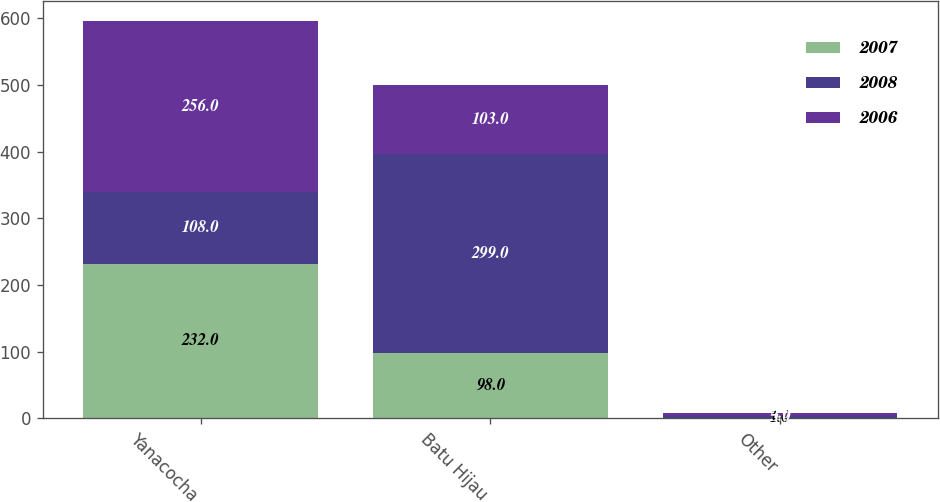<chart> <loc_0><loc_0><loc_500><loc_500><stacked_bar_chart><ecel><fcel>Yanacocha<fcel>Batu Hijau<fcel>Other<nl><fcel>2007<fcel>232<fcel>98<fcel>1<nl><fcel>2008<fcel>108<fcel>299<fcel>3<nl><fcel>2006<fcel>256<fcel>103<fcel>4<nl></chart> 